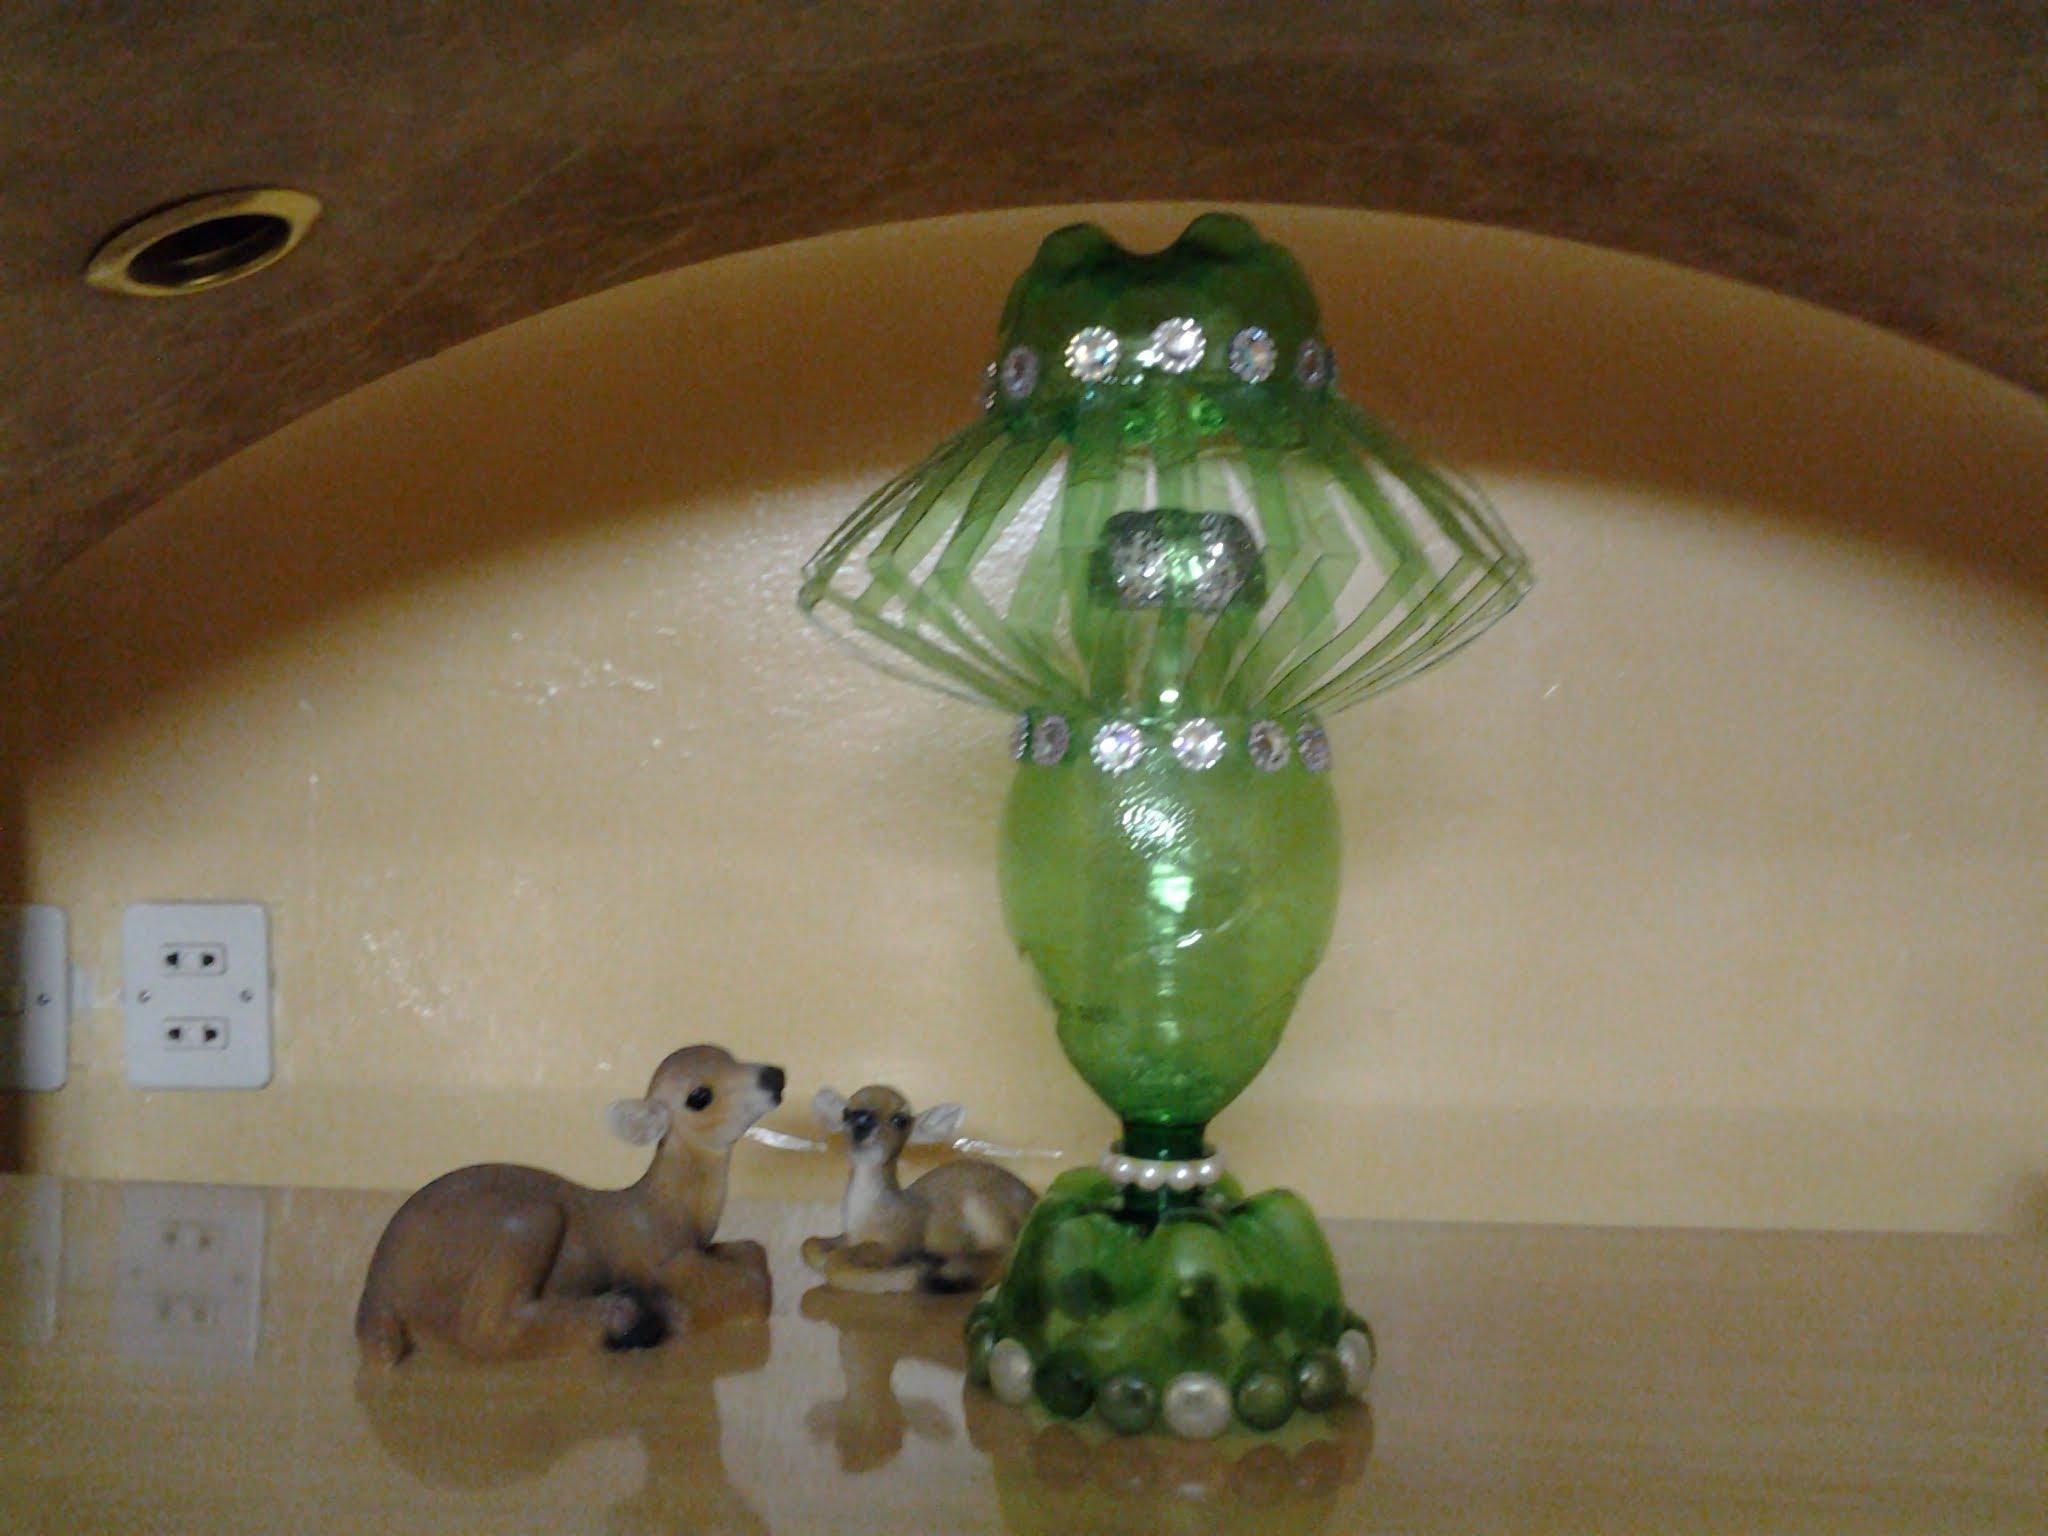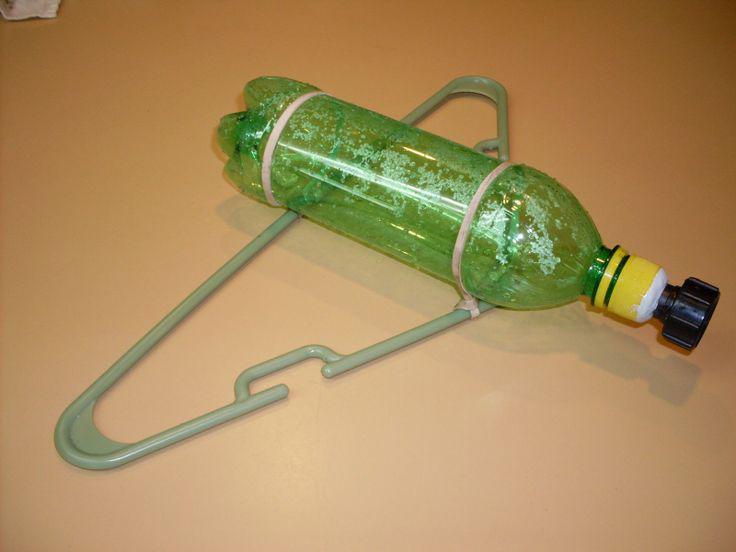The first image is the image on the left, the second image is the image on the right. Assess this claim about the two images: "In one of the images, the plastic bottles have been remade into containers that look like apples.". Correct or not? Answer yes or no. No. The first image is the image on the left, the second image is the image on the right. Evaluate the accuracy of this statement regarding the images: "The right image shows something holding a green bottle horizontally with its top end to the right.". Is it true? Answer yes or no. Yes. 